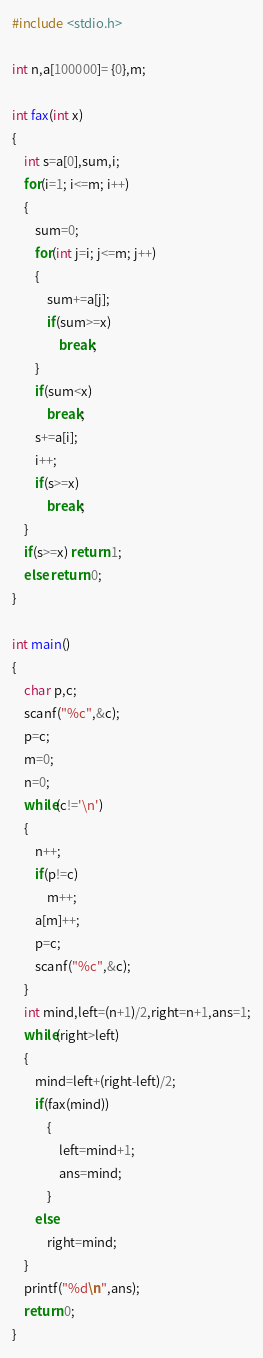Convert code to text. <code><loc_0><loc_0><loc_500><loc_500><_C_>#include <stdio.h>

int n,a[100000]= {0},m;

int fax(int x)
{
    int s=a[0],sum,i;
    for(i=1; i<=m; i++)
    {
        sum=0;
        for(int j=i; j<=m; j++)
        {
            sum+=a[j];
            if(sum>=x)
                break;
        }
        if(sum<x)
            break;
        s+=a[i];
        i++;
        if(s>=x)
            break;
    }
    if(s>=x) return 1;
    else return 0;
}

int main()
{
    char p,c;
    scanf("%c",&c);
    p=c;
    m=0;
    n=0;
    while(c!='\n')
    {
        n++;
        if(p!=c)
            m++;
        a[m]++;
        p=c;
        scanf("%c",&c);
    }
    int mind,left=(n+1)/2,right=n+1,ans=1;
    while(right>left)
    {
        mind=left+(right-left)/2;
        if(fax(mind))
            {
                left=mind+1;
                ans=mind;
            }
        else
            right=mind;
    }
    printf("%d\n",ans);
    return 0;
}
</code> 